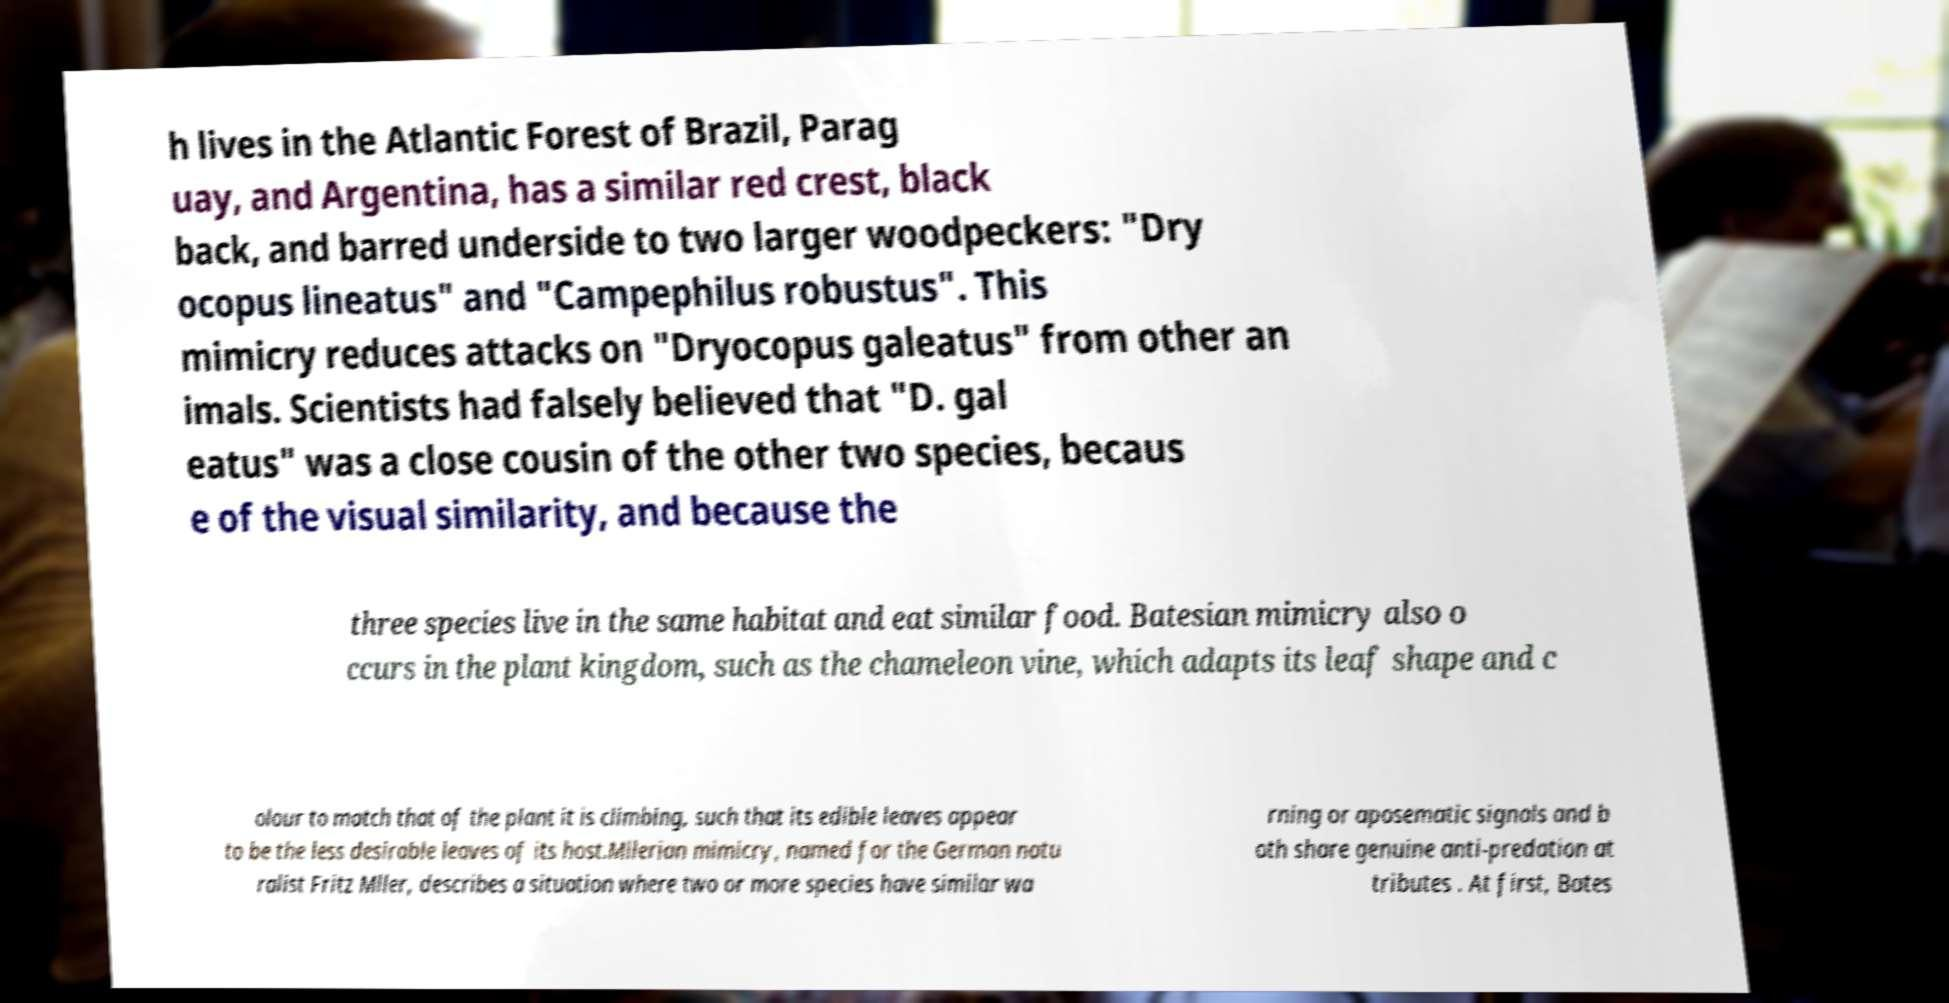Can you accurately transcribe the text from the provided image for me? h lives in the Atlantic Forest of Brazil, Parag uay, and Argentina, has a similar red crest, black back, and barred underside to two larger woodpeckers: "Dry ocopus lineatus" and "Campephilus robustus". This mimicry reduces attacks on "Dryocopus galeatus" from other an imals. Scientists had falsely believed that "D. gal eatus" was a close cousin of the other two species, becaus e of the visual similarity, and because the three species live in the same habitat and eat similar food. Batesian mimicry also o ccurs in the plant kingdom, such as the chameleon vine, which adapts its leaf shape and c olour to match that of the plant it is climbing, such that its edible leaves appear to be the less desirable leaves of its host.Mllerian mimicry, named for the German natu ralist Fritz Mller, describes a situation where two or more species have similar wa rning or aposematic signals and b oth share genuine anti-predation at tributes . At first, Bates 